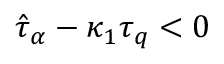Convert formula to latex. <formula><loc_0><loc_0><loc_500><loc_500>\hat { \tau } _ { \alpha } - \kappa _ { 1 } \tau _ { q } < 0</formula> 